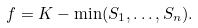Convert formula to latex. <formula><loc_0><loc_0><loc_500><loc_500>f = K - \min ( S _ { 1 } , \dots , S _ { n } ) .</formula> 